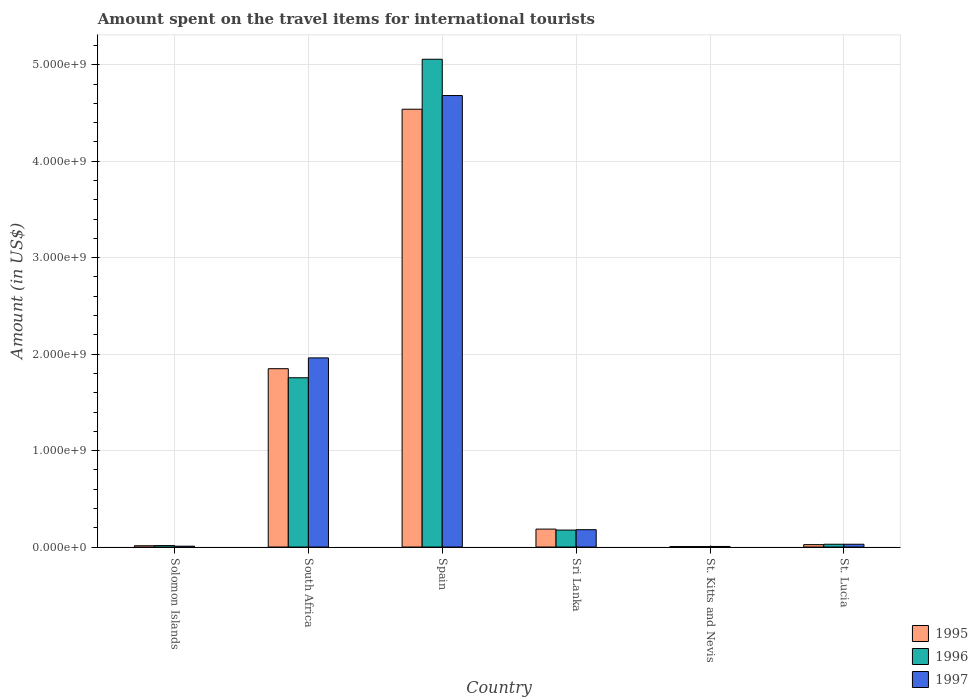Are the number of bars per tick equal to the number of legend labels?
Your answer should be very brief. Yes. Are the number of bars on each tick of the X-axis equal?
Provide a succinct answer. Yes. How many bars are there on the 5th tick from the right?
Ensure brevity in your answer.  3. What is the label of the 6th group of bars from the left?
Provide a short and direct response. St. Lucia. In how many cases, is the number of bars for a given country not equal to the number of legend labels?
Provide a short and direct response. 0. What is the amount spent on the travel items for international tourists in 1995 in Solomon Islands?
Your answer should be very brief. 1.35e+07. Across all countries, what is the maximum amount spent on the travel items for international tourists in 1996?
Your answer should be compact. 5.06e+09. Across all countries, what is the minimum amount spent on the travel items for international tourists in 1996?
Make the answer very short. 5.00e+06. In which country was the amount spent on the travel items for international tourists in 1996 minimum?
Provide a short and direct response. St. Kitts and Nevis. What is the total amount spent on the travel items for international tourists in 1996 in the graph?
Your answer should be compact. 7.04e+09. What is the difference between the amount spent on the travel items for international tourists in 1995 in Solomon Islands and that in Sri Lanka?
Your response must be concise. -1.72e+08. What is the difference between the amount spent on the travel items for international tourists in 1995 in St. Lucia and the amount spent on the travel items for international tourists in 1997 in South Africa?
Offer a terse response. -1.94e+09. What is the average amount spent on the travel items for international tourists in 1995 per country?
Provide a succinct answer. 1.10e+09. What is the ratio of the amount spent on the travel items for international tourists in 1995 in South Africa to that in Sri Lanka?
Offer a very short reply. 9.94. What is the difference between the highest and the second highest amount spent on the travel items for international tourists in 1995?
Give a very brief answer. 2.69e+09. What is the difference between the highest and the lowest amount spent on the travel items for international tourists in 1996?
Offer a very short reply. 5.05e+09. What does the 2nd bar from the left in Spain represents?
Make the answer very short. 1996. How many bars are there?
Give a very brief answer. 18. Are all the bars in the graph horizontal?
Give a very brief answer. No. What is the difference between two consecutive major ticks on the Y-axis?
Provide a succinct answer. 1.00e+09. How many legend labels are there?
Ensure brevity in your answer.  3. How are the legend labels stacked?
Give a very brief answer. Vertical. What is the title of the graph?
Your answer should be very brief. Amount spent on the travel items for international tourists. What is the Amount (in US$) in 1995 in Solomon Islands?
Offer a very short reply. 1.35e+07. What is the Amount (in US$) in 1996 in Solomon Islands?
Offer a terse response. 1.52e+07. What is the Amount (in US$) in 1997 in Solomon Islands?
Keep it short and to the point. 9.00e+06. What is the Amount (in US$) of 1995 in South Africa?
Keep it short and to the point. 1.85e+09. What is the Amount (in US$) of 1996 in South Africa?
Offer a very short reply. 1.76e+09. What is the Amount (in US$) of 1997 in South Africa?
Your answer should be very brief. 1.96e+09. What is the Amount (in US$) in 1995 in Spain?
Provide a succinct answer. 4.54e+09. What is the Amount (in US$) in 1996 in Spain?
Provide a succinct answer. 5.06e+09. What is the Amount (in US$) of 1997 in Spain?
Provide a succinct answer. 4.68e+09. What is the Amount (in US$) in 1995 in Sri Lanka?
Offer a terse response. 1.86e+08. What is the Amount (in US$) of 1996 in Sri Lanka?
Offer a very short reply. 1.76e+08. What is the Amount (in US$) of 1997 in Sri Lanka?
Make the answer very short. 1.80e+08. What is the Amount (in US$) in 1996 in St. Kitts and Nevis?
Offer a terse response. 5.00e+06. What is the Amount (in US$) of 1997 in St. Kitts and Nevis?
Make the answer very short. 6.00e+06. What is the Amount (in US$) in 1995 in St. Lucia?
Give a very brief answer. 2.50e+07. What is the Amount (in US$) in 1996 in St. Lucia?
Provide a succinct answer. 2.90e+07. What is the Amount (in US$) of 1997 in St. Lucia?
Offer a terse response. 2.90e+07. Across all countries, what is the maximum Amount (in US$) in 1995?
Provide a short and direct response. 4.54e+09. Across all countries, what is the maximum Amount (in US$) of 1996?
Offer a terse response. 5.06e+09. Across all countries, what is the maximum Amount (in US$) of 1997?
Ensure brevity in your answer.  4.68e+09. Across all countries, what is the minimum Amount (in US$) in 1995?
Provide a succinct answer. 5.00e+06. Across all countries, what is the minimum Amount (in US$) in 1996?
Offer a terse response. 5.00e+06. What is the total Amount (in US$) in 1995 in the graph?
Offer a very short reply. 6.62e+09. What is the total Amount (in US$) in 1996 in the graph?
Offer a very short reply. 7.04e+09. What is the total Amount (in US$) of 1997 in the graph?
Provide a short and direct response. 6.87e+09. What is the difference between the Amount (in US$) in 1995 in Solomon Islands and that in South Africa?
Offer a terse response. -1.84e+09. What is the difference between the Amount (in US$) in 1996 in Solomon Islands and that in South Africa?
Your answer should be compact. -1.74e+09. What is the difference between the Amount (in US$) in 1997 in Solomon Islands and that in South Africa?
Ensure brevity in your answer.  -1.95e+09. What is the difference between the Amount (in US$) of 1995 in Solomon Islands and that in Spain?
Keep it short and to the point. -4.53e+09. What is the difference between the Amount (in US$) of 1996 in Solomon Islands and that in Spain?
Provide a short and direct response. -5.04e+09. What is the difference between the Amount (in US$) of 1997 in Solomon Islands and that in Spain?
Offer a terse response. -4.67e+09. What is the difference between the Amount (in US$) of 1995 in Solomon Islands and that in Sri Lanka?
Offer a terse response. -1.72e+08. What is the difference between the Amount (in US$) in 1996 in Solomon Islands and that in Sri Lanka?
Ensure brevity in your answer.  -1.61e+08. What is the difference between the Amount (in US$) in 1997 in Solomon Islands and that in Sri Lanka?
Offer a very short reply. -1.71e+08. What is the difference between the Amount (in US$) in 1995 in Solomon Islands and that in St. Kitts and Nevis?
Provide a succinct answer. 8.50e+06. What is the difference between the Amount (in US$) of 1996 in Solomon Islands and that in St. Kitts and Nevis?
Ensure brevity in your answer.  1.02e+07. What is the difference between the Amount (in US$) of 1997 in Solomon Islands and that in St. Kitts and Nevis?
Keep it short and to the point. 3.00e+06. What is the difference between the Amount (in US$) in 1995 in Solomon Islands and that in St. Lucia?
Your answer should be compact. -1.15e+07. What is the difference between the Amount (in US$) of 1996 in Solomon Islands and that in St. Lucia?
Make the answer very short. -1.38e+07. What is the difference between the Amount (in US$) of 1997 in Solomon Islands and that in St. Lucia?
Provide a succinct answer. -2.00e+07. What is the difference between the Amount (in US$) of 1995 in South Africa and that in Spain?
Make the answer very short. -2.69e+09. What is the difference between the Amount (in US$) in 1996 in South Africa and that in Spain?
Provide a succinct answer. -3.30e+09. What is the difference between the Amount (in US$) in 1997 in South Africa and that in Spain?
Your answer should be compact. -2.72e+09. What is the difference between the Amount (in US$) in 1995 in South Africa and that in Sri Lanka?
Make the answer very short. 1.66e+09. What is the difference between the Amount (in US$) in 1996 in South Africa and that in Sri Lanka?
Offer a very short reply. 1.58e+09. What is the difference between the Amount (in US$) in 1997 in South Africa and that in Sri Lanka?
Your answer should be compact. 1.78e+09. What is the difference between the Amount (in US$) in 1995 in South Africa and that in St. Kitts and Nevis?
Your answer should be compact. 1.84e+09. What is the difference between the Amount (in US$) in 1996 in South Africa and that in St. Kitts and Nevis?
Your response must be concise. 1.75e+09. What is the difference between the Amount (in US$) in 1997 in South Africa and that in St. Kitts and Nevis?
Provide a succinct answer. 1.96e+09. What is the difference between the Amount (in US$) of 1995 in South Africa and that in St. Lucia?
Make the answer very short. 1.82e+09. What is the difference between the Amount (in US$) in 1996 in South Africa and that in St. Lucia?
Make the answer very short. 1.73e+09. What is the difference between the Amount (in US$) of 1997 in South Africa and that in St. Lucia?
Offer a very short reply. 1.93e+09. What is the difference between the Amount (in US$) in 1995 in Spain and that in Sri Lanka?
Ensure brevity in your answer.  4.35e+09. What is the difference between the Amount (in US$) in 1996 in Spain and that in Sri Lanka?
Make the answer very short. 4.88e+09. What is the difference between the Amount (in US$) in 1997 in Spain and that in Sri Lanka?
Offer a terse response. 4.50e+09. What is the difference between the Amount (in US$) of 1995 in Spain and that in St. Kitts and Nevis?
Give a very brief answer. 4.53e+09. What is the difference between the Amount (in US$) in 1996 in Spain and that in St. Kitts and Nevis?
Ensure brevity in your answer.  5.05e+09. What is the difference between the Amount (in US$) of 1997 in Spain and that in St. Kitts and Nevis?
Make the answer very short. 4.68e+09. What is the difference between the Amount (in US$) of 1995 in Spain and that in St. Lucia?
Your response must be concise. 4.51e+09. What is the difference between the Amount (in US$) in 1996 in Spain and that in St. Lucia?
Offer a terse response. 5.03e+09. What is the difference between the Amount (in US$) of 1997 in Spain and that in St. Lucia?
Ensure brevity in your answer.  4.65e+09. What is the difference between the Amount (in US$) in 1995 in Sri Lanka and that in St. Kitts and Nevis?
Provide a succinct answer. 1.81e+08. What is the difference between the Amount (in US$) of 1996 in Sri Lanka and that in St. Kitts and Nevis?
Your answer should be very brief. 1.71e+08. What is the difference between the Amount (in US$) of 1997 in Sri Lanka and that in St. Kitts and Nevis?
Offer a terse response. 1.74e+08. What is the difference between the Amount (in US$) of 1995 in Sri Lanka and that in St. Lucia?
Ensure brevity in your answer.  1.61e+08. What is the difference between the Amount (in US$) in 1996 in Sri Lanka and that in St. Lucia?
Your answer should be very brief. 1.47e+08. What is the difference between the Amount (in US$) in 1997 in Sri Lanka and that in St. Lucia?
Make the answer very short. 1.51e+08. What is the difference between the Amount (in US$) of 1995 in St. Kitts and Nevis and that in St. Lucia?
Make the answer very short. -2.00e+07. What is the difference between the Amount (in US$) in 1996 in St. Kitts and Nevis and that in St. Lucia?
Make the answer very short. -2.40e+07. What is the difference between the Amount (in US$) in 1997 in St. Kitts and Nevis and that in St. Lucia?
Keep it short and to the point. -2.30e+07. What is the difference between the Amount (in US$) in 1995 in Solomon Islands and the Amount (in US$) in 1996 in South Africa?
Ensure brevity in your answer.  -1.74e+09. What is the difference between the Amount (in US$) in 1995 in Solomon Islands and the Amount (in US$) in 1997 in South Africa?
Your response must be concise. -1.95e+09. What is the difference between the Amount (in US$) in 1996 in Solomon Islands and the Amount (in US$) in 1997 in South Africa?
Offer a very short reply. -1.95e+09. What is the difference between the Amount (in US$) of 1995 in Solomon Islands and the Amount (in US$) of 1996 in Spain?
Your answer should be very brief. -5.04e+09. What is the difference between the Amount (in US$) in 1995 in Solomon Islands and the Amount (in US$) in 1997 in Spain?
Provide a succinct answer. -4.67e+09. What is the difference between the Amount (in US$) in 1996 in Solomon Islands and the Amount (in US$) in 1997 in Spain?
Keep it short and to the point. -4.67e+09. What is the difference between the Amount (in US$) of 1995 in Solomon Islands and the Amount (in US$) of 1996 in Sri Lanka?
Make the answer very short. -1.62e+08. What is the difference between the Amount (in US$) in 1995 in Solomon Islands and the Amount (in US$) in 1997 in Sri Lanka?
Your response must be concise. -1.66e+08. What is the difference between the Amount (in US$) in 1996 in Solomon Islands and the Amount (in US$) in 1997 in Sri Lanka?
Your response must be concise. -1.65e+08. What is the difference between the Amount (in US$) in 1995 in Solomon Islands and the Amount (in US$) in 1996 in St. Kitts and Nevis?
Give a very brief answer. 8.50e+06. What is the difference between the Amount (in US$) in 1995 in Solomon Islands and the Amount (in US$) in 1997 in St. Kitts and Nevis?
Offer a very short reply. 7.50e+06. What is the difference between the Amount (in US$) of 1996 in Solomon Islands and the Amount (in US$) of 1997 in St. Kitts and Nevis?
Give a very brief answer. 9.20e+06. What is the difference between the Amount (in US$) in 1995 in Solomon Islands and the Amount (in US$) in 1996 in St. Lucia?
Keep it short and to the point. -1.55e+07. What is the difference between the Amount (in US$) in 1995 in Solomon Islands and the Amount (in US$) in 1997 in St. Lucia?
Offer a very short reply. -1.55e+07. What is the difference between the Amount (in US$) in 1996 in Solomon Islands and the Amount (in US$) in 1997 in St. Lucia?
Ensure brevity in your answer.  -1.38e+07. What is the difference between the Amount (in US$) of 1995 in South Africa and the Amount (in US$) of 1996 in Spain?
Your answer should be very brief. -3.21e+09. What is the difference between the Amount (in US$) in 1995 in South Africa and the Amount (in US$) in 1997 in Spain?
Keep it short and to the point. -2.83e+09. What is the difference between the Amount (in US$) of 1996 in South Africa and the Amount (in US$) of 1997 in Spain?
Keep it short and to the point. -2.93e+09. What is the difference between the Amount (in US$) of 1995 in South Africa and the Amount (in US$) of 1996 in Sri Lanka?
Ensure brevity in your answer.  1.67e+09. What is the difference between the Amount (in US$) in 1995 in South Africa and the Amount (in US$) in 1997 in Sri Lanka?
Your response must be concise. 1.67e+09. What is the difference between the Amount (in US$) of 1996 in South Africa and the Amount (in US$) of 1997 in Sri Lanka?
Your answer should be compact. 1.58e+09. What is the difference between the Amount (in US$) in 1995 in South Africa and the Amount (in US$) in 1996 in St. Kitts and Nevis?
Give a very brief answer. 1.84e+09. What is the difference between the Amount (in US$) in 1995 in South Africa and the Amount (in US$) in 1997 in St. Kitts and Nevis?
Your answer should be compact. 1.84e+09. What is the difference between the Amount (in US$) in 1996 in South Africa and the Amount (in US$) in 1997 in St. Kitts and Nevis?
Your answer should be very brief. 1.75e+09. What is the difference between the Amount (in US$) of 1995 in South Africa and the Amount (in US$) of 1996 in St. Lucia?
Offer a terse response. 1.82e+09. What is the difference between the Amount (in US$) of 1995 in South Africa and the Amount (in US$) of 1997 in St. Lucia?
Your answer should be compact. 1.82e+09. What is the difference between the Amount (in US$) of 1996 in South Africa and the Amount (in US$) of 1997 in St. Lucia?
Your response must be concise. 1.73e+09. What is the difference between the Amount (in US$) of 1995 in Spain and the Amount (in US$) of 1996 in Sri Lanka?
Keep it short and to the point. 4.36e+09. What is the difference between the Amount (in US$) of 1995 in Spain and the Amount (in US$) of 1997 in Sri Lanka?
Keep it short and to the point. 4.36e+09. What is the difference between the Amount (in US$) in 1996 in Spain and the Amount (in US$) in 1997 in Sri Lanka?
Provide a succinct answer. 4.88e+09. What is the difference between the Amount (in US$) in 1995 in Spain and the Amount (in US$) in 1996 in St. Kitts and Nevis?
Provide a succinct answer. 4.53e+09. What is the difference between the Amount (in US$) of 1995 in Spain and the Amount (in US$) of 1997 in St. Kitts and Nevis?
Your answer should be compact. 4.53e+09. What is the difference between the Amount (in US$) in 1996 in Spain and the Amount (in US$) in 1997 in St. Kitts and Nevis?
Make the answer very short. 5.05e+09. What is the difference between the Amount (in US$) of 1995 in Spain and the Amount (in US$) of 1996 in St. Lucia?
Provide a succinct answer. 4.51e+09. What is the difference between the Amount (in US$) in 1995 in Spain and the Amount (in US$) in 1997 in St. Lucia?
Your answer should be compact. 4.51e+09. What is the difference between the Amount (in US$) in 1996 in Spain and the Amount (in US$) in 1997 in St. Lucia?
Your response must be concise. 5.03e+09. What is the difference between the Amount (in US$) in 1995 in Sri Lanka and the Amount (in US$) in 1996 in St. Kitts and Nevis?
Your response must be concise. 1.81e+08. What is the difference between the Amount (in US$) in 1995 in Sri Lanka and the Amount (in US$) in 1997 in St. Kitts and Nevis?
Give a very brief answer. 1.80e+08. What is the difference between the Amount (in US$) in 1996 in Sri Lanka and the Amount (in US$) in 1997 in St. Kitts and Nevis?
Ensure brevity in your answer.  1.70e+08. What is the difference between the Amount (in US$) of 1995 in Sri Lanka and the Amount (in US$) of 1996 in St. Lucia?
Offer a terse response. 1.57e+08. What is the difference between the Amount (in US$) in 1995 in Sri Lanka and the Amount (in US$) in 1997 in St. Lucia?
Provide a short and direct response. 1.57e+08. What is the difference between the Amount (in US$) of 1996 in Sri Lanka and the Amount (in US$) of 1997 in St. Lucia?
Keep it short and to the point. 1.47e+08. What is the difference between the Amount (in US$) of 1995 in St. Kitts and Nevis and the Amount (in US$) of 1996 in St. Lucia?
Offer a terse response. -2.40e+07. What is the difference between the Amount (in US$) of 1995 in St. Kitts and Nevis and the Amount (in US$) of 1997 in St. Lucia?
Your answer should be compact. -2.40e+07. What is the difference between the Amount (in US$) of 1996 in St. Kitts and Nevis and the Amount (in US$) of 1997 in St. Lucia?
Ensure brevity in your answer.  -2.40e+07. What is the average Amount (in US$) in 1995 per country?
Your response must be concise. 1.10e+09. What is the average Amount (in US$) of 1996 per country?
Your answer should be very brief. 1.17e+09. What is the average Amount (in US$) in 1997 per country?
Provide a short and direct response. 1.14e+09. What is the difference between the Amount (in US$) in 1995 and Amount (in US$) in 1996 in Solomon Islands?
Make the answer very short. -1.70e+06. What is the difference between the Amount (in US$) in 1995 and Amount (in US$) in 1997 in Solomon Islands?
Give a very brief answer. 4.50e+06. What is the difference between the Amount (in US$) in 1996 and Amount (in US$) in 1997 in Solomon Islands?
Provide a short and direct response. 6.20e+06. What is the difference between the Amount (in US$) in 1995 and Amount (in US$) in 1996 in South Africa?
Provide a succinct answer. 9.40e+07. What is the difference between the Amount (in US$) of 1995 and Amount (in US$) of 1997 in South Africa?
Give a very brief answer. -1.12e+08. What is the difference between the Amount (in US$) of 1996 and Amount (in US$) of 1997 in South Africa?
Provide a succinct answer. -2.06e+08. What is the difference between the Amount (in US$) in 1995 and Amount (in US$) in 1996 in Spain?
Provide a succinct answer. -5.18e+08. What is the difference between the Amount (in US$) of 1995 and Amount (in US$) of 1997 in Spain?
Make the answer very short. -1.42e+08. What is the difference between the Amount (in US$) of 1996 and Amount (in US$) of 1997 in Spain?
Provide a short and direct response. 3.76e+08. What is the difference between the Amount (in US$) in 1995 and Amount (in US$) in 1996 in Sri Lanka?
Provide a succinct answer. 1.00e+07. What is the difference between the Amount (in US$) in 1995 and Amount (in US$) in 1996 in St. Kitts and Nevis?
Your answer should be compact. 0. What is the difference between the Amount (in US$) of 1995 and Amount (in US$) of 1996 in St. Lucia?
Your answer should be very brief. -4.00e+06. What is the difference between the Amount (in US$) in 1995 and Amount (in US$) in 1997 in St. Lucia?
Provide a succinct answer. -4.00e+06. What is the ratio of the Amount (in US$) in 1995 in Solomon Islands to that in South Africa?
Your answer should be very brief. 0.01. What is the ratio of the Amount (in US$) in 1996 in Solomon Islands to that in South Africa?
Your answer should be compact. 0.01. What is the ratio of the Amount (in US$) of 1997 in Solomon Islands to that in South Africa?
Your answer should be very brief. 0. What is the ratio of the Amount (in US$) of 1995 in Solomon Islands to that in Spain?
Offer a very short reply. 0. What is the ratio of the Amount (in US$) in 1996 in Solomon Islands to that in Spain?
Ensure brevity in your answer.  0. What is the ratio of the Amount (in US$) in 1997 in Solomon Islands to that in Spain?
Make the answer very short. 0. What is the ratio of the Amount (in US$) of 1995 in Solomon Islands to that in Sri Lanka?
Ensure brevity in your answer.  0.07. What is the ratio of the Amount (in US$) of 1996 in Solomon Islands to that in Sri Lanka?
Ensure brevity in your answer.  0.09. What is the ratio of the Amount (in US$) in 1997 in Solomon Islands to that in Sri Lanka?
Give a very brief answer. 0.05. What is the ratio of the Amount (in US$) in 1995 in Solomon Islands to that in St. Kitts and Nevis?
Your response must be concise. 2.7. What is the ratio of the Amount (in US$) of 1996 in Solomon Islands to that in St. Kitts and Nevis?
Provide a succinct answer. 3.04. What is the ratio of the Amount (in US$) of 1995 in Solomon Islands to that in St. Lucia?
Provide a succinct answer. 0.54. What is the ratio of the Amount (in US$) of 1996 in Solomon Islands to that in St. Lucia?
Your answer should be compact. 0.52. What is the ratio of the Amount (in US$) of 1997 in Solomon Islands to that in St. Lucia?
Ensure brevity in your answer.  0.31. What is the ratio of the Amount (in US$) of 1995 in South Africa to that in Spain?
Your answer should be very brief. 0.41. What is the ratio of the Amount (in US$) of 1996 in South Africa to that in Spain?
Your response must be concise. 0.35. What is the ratio of the Amount (in US$) in 1997 in South Africa to that in Spain?
Offer a terse response. 0.42. What is the ratio of the Amount (in US$) of 1995 in South Africa to that in Sri Lanka?
Keep it short and to the point. 9.94. What is the ratio of the Amount (in US$) of 1996 in South Africa to that in Sri Lanka?
Offer a very short reply. 9.97. What is the ratio of the Amount (in US$) in 1997 in South Africa to that in Sri Lanka?
Give a very brief answer. 10.89. What is the ratio of the Amount (in US$) in 1995 in South Africa to that in St. Kitts and Nevis?
Keep it short and to the point. 369.8. What is the ratio of the Amount (in US$) in 1996 in South Africa to that in St. Kitts and Nevis?
Ensure brevity in your answer.  351. What is the ratio of the Amount (in US$) of 1997 in South Africa to that in St. Kitts and Nevis?
Your response must be concise. 326.83. What is the ratio of the Amount (in US$) in 1995 in South Africa to that in St. Lucia?
Give a very brief answer. 73.96. What is the ratio of the Amount (in US$) in 1996 in South Africa to that in St. Lucia?
Offer a terse response. 60.52. What is the ratio of the Amount (in US$) in 1997 in South Africa to that in St. Lucia?
Your answer should be compact. 67.62. What is the ratio of the Amount (in US$) of 1995 in Spain to that in Sri Lanka?
Ensure brevity in your answer.  24.4. What is the ratio of the Amount (in US$) of 1996 in Spain to that in Sri Lanka?
Keep it short and to the point. 28.73. What is the ratio of the Amount (in US$) of 1997 in Spain to that in Sri Lanka?
Provide a succinct answer. 26.01. What is the ratio of the Amount (in US$) of 1995 in Spain to that in St. Kitts and Nevis?
Keep it short and to the point. 907.8. What is the ratio of the Amount (in US$) of 1996 in Spain to that in St. Kitts and Nevis?
Ensure brevity in your answer.  1011.4. What is the ratio of the Amount (in US$) in 1997 in Spain to that in St. Kitts and Nevis?
Your response must be concise. 780.17. What is the ratio of the Amount (in US$) of 1995 in Spain to that in St. Lucia?
Offer a very short reply. 181.56. What is the ratio of the Amount (in US$) in 1996 in Spain to that in St. Lucia?
Give a very brief answer. 174.38. What is the ratio of the Amount (in US$) of 1997 in Spain to that in St. Lucia?
Ensure brevity in your answer.  161.41. What is the ratio of the Amount (in US$) of 1995 in Sri Lanka to that in St. Kitts and Nevis?
Keep it short and to the point. 37.2. What is the ratio of the Amount (in US$) in 1996 in Sri Lanka to that in St. Kitts and Nevis?
Keep it short and to the point. 35.2. What is the ratio of the Amount (in US$) in 1997 in Sri Lanka to that in St. Kitts and Nevis?
Provide a succinct answer. 30. What is the ratio of the Amount (in US$) of 1995 in Sri Lanka to that in St. Lucia?
Offer a terse response. 7.44. What is the ratio of the Amount (in US$) of 1996 in Sri Lanka to that in St. Lucia?
Make the answer very short. 6.07. What is the ratio of the Amount (in US$) in 1997 in Sri Lanka to that in St. Lucia?
Give a very brief answer. 6.21. What is the ratio of the Amount (in US$) in 1995 in St. Kitts and Nevis to that in St. Lucia?
Keep it short and to the point. 0.2. What is the ratio of the Amount (in US$) of 1996 in St. Kitts and Nevis to that in St. Lucia?
Keep it short and to the point. 0.17. What is the ratio of the Amount (in US$) in 1997 in St. Kitts and Nevis to that in St. Lucia?
Your answer should be very brief. 0.21. What is the difference between the highest and the second highest Amount (in US$) in 1995?
Ensure brevity in your answer.  2.69e+09. What is the difference between the highest and the second highest Amount (in US$) of 1996?
Give a very brief answer. 3.30e+09. What is the difference between the highest and the second highest Amount (in US$) in 1997?
Your answer should be very brief. 2.72e+09. What is the difference between the highest and the lowest Amount (in US$) in 1995?
Provide a short and direct response. 4.53e+09. What is the difference between the highest and the lowest Amount (in US$) in 1996?
Offer a very short reply. 5.05e+09. What is the difference between the highest and the lowest Amount (in US$) in 1997?
Your answer should be very brief. 4.68e+09. 